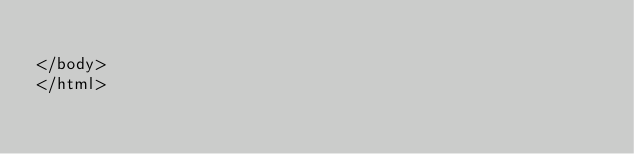<code> <loc_0><loc_0><loc_500><loc_500><_PHP_>
</body>
</html></code> 